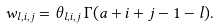Convert formula to latex. <formula><loc_0><loc_0><loc_500><loc_500>w _ { l , i , j } = \theta _ { l , i , j } \, \Gamma ( a + i + j - 1 - l ) .</formula> 